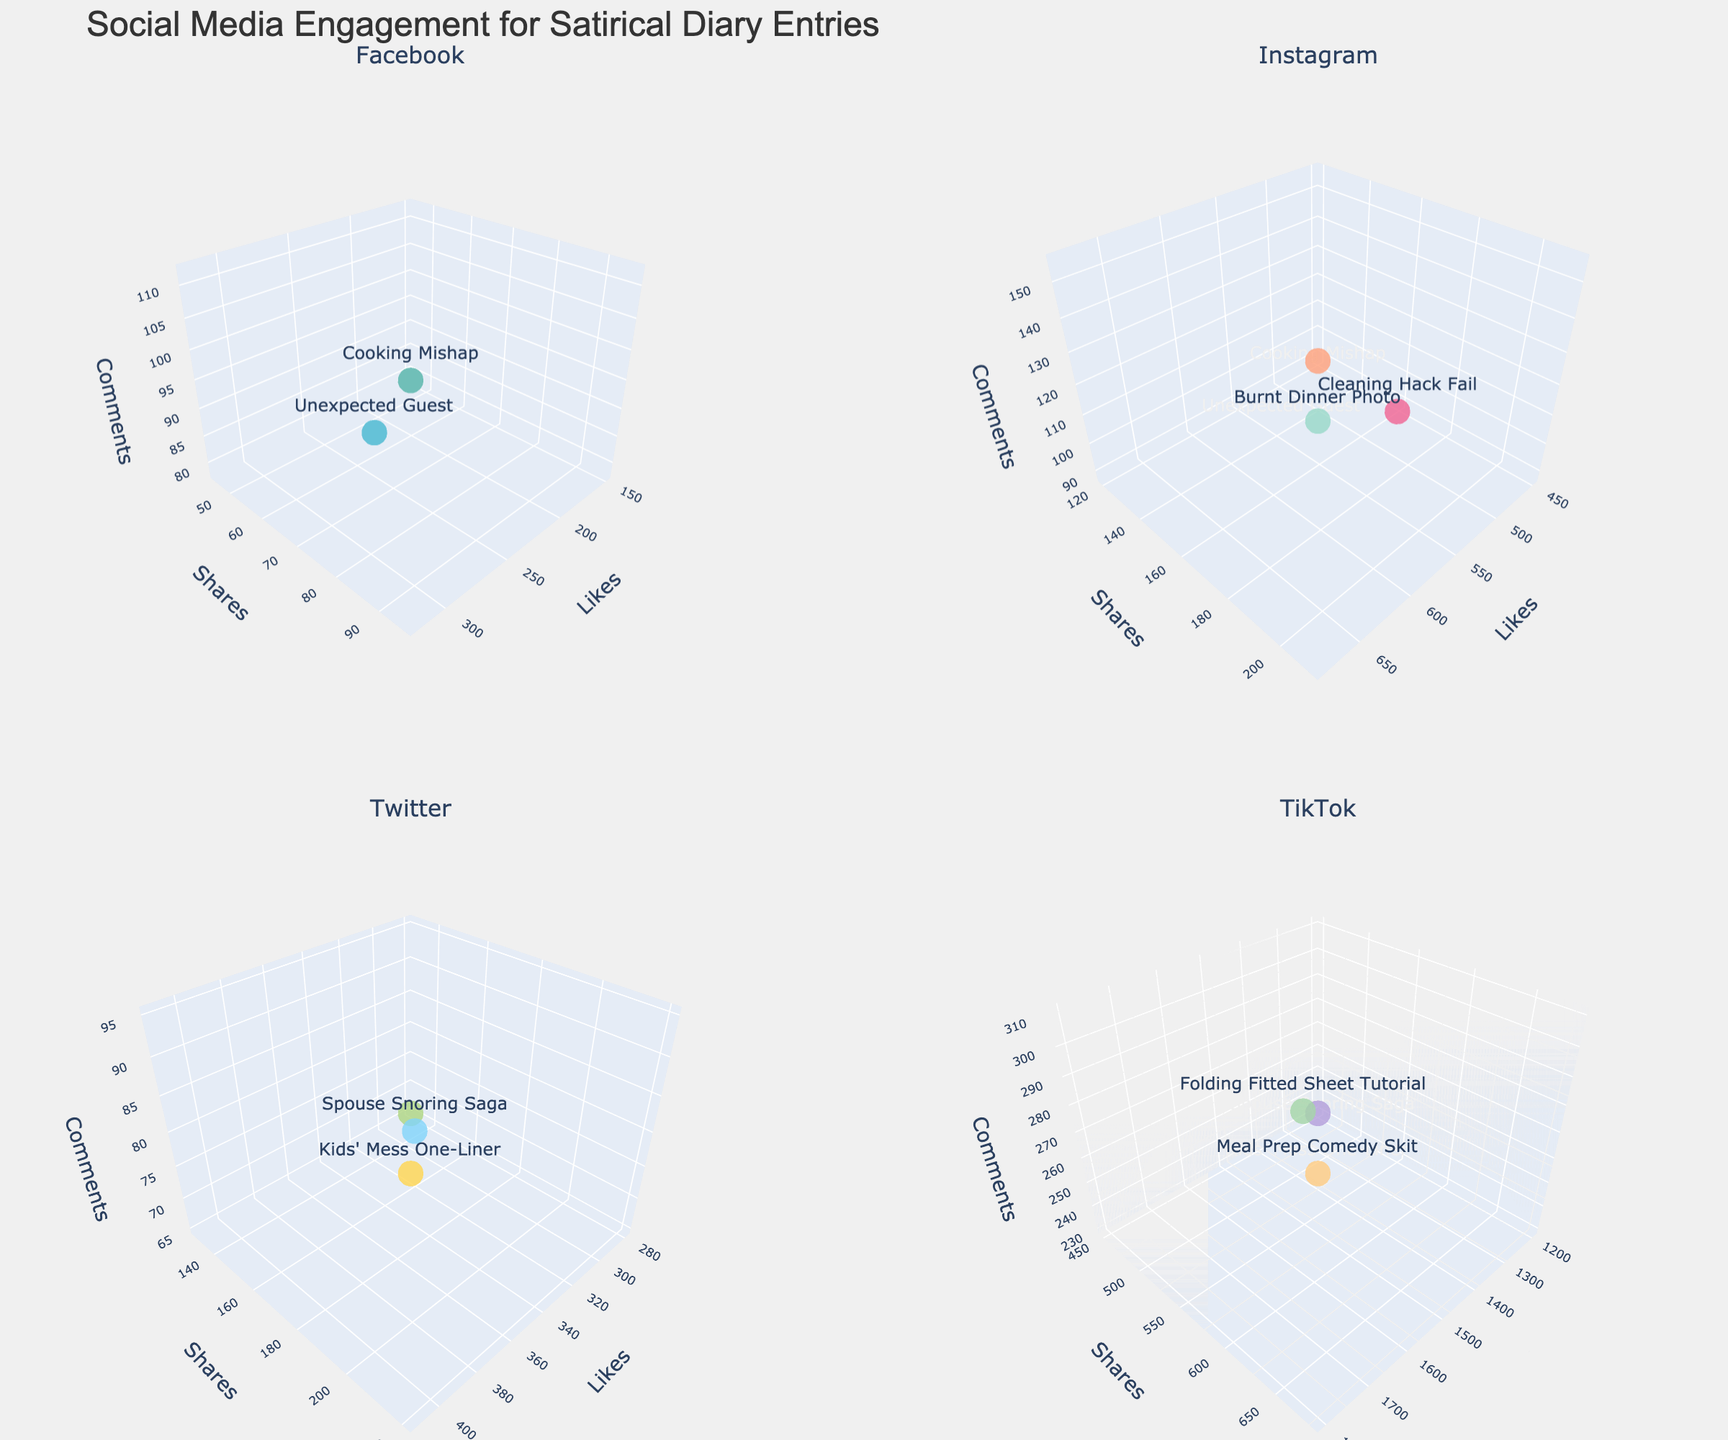What platforms are represented in the figure? The subplot titles indicate the platforms represented: Facebook, Instagram, Twitter, and TikTok.
Answer: Facebook, Instagram, Twitter, TikTok How many post types are plotted for Facebook? Looking at the subplot for Facebook, there are three distinct colored markers, each labeled with a different post type.
Answer: 3 Which platform has the post type with the highest number of likes? In the subplot for TikTok, the "Meal Prep Comedy Skit" has 1800 likes, which is the highest number of likes among all post types across all platforms.
Answer: TikTok Compare the shares of "Burnt Dinner Photo" on Instagram and "Spouse Snoring Saga" on Twitter. Which one has more shares? "Burnt Dinner Photo" on Instagram has 210 shares, while "Spouse Snoring Saga" on Twitter has 180 shares. Therefore, "Burnt Dinner Photo" has more shares.
Answer: Burnt Dinner Photo What is the color used for the "Folding Fitted Sheet Tutorial" post type on TikTok? The color map indicates that "Folding Fitted Sheet Tutorial" is represented by a shade of light green.
Answer: Light Green How many comments does "Grocery List Haiku" on Twitter have, and is this more or less than the comments on "Daily Chore Rant" on Facebook? "Grocery List Haiku" on Twitter has 65 comments, while "Daily Chore Rant" on Facebook has 78 comments. So, it has fewer comments.
Answer: Less What post type has the least engagement (combining likes, shares, and comments) on LinkedIn? "Work-Life Balance Satire" on LinkedIn has the lowest engagement with 85 likes, 30 shares, and 42 comments, summing to 157. This is lower than the other post types on LinkedIn.
Answer: Work-Life Balance Satire Which platform shows a wider spread of comments among its post types: Instagram or Twitter? Examining the range of the z-axes (comments) for Instagram and Twitter, Twitter has a wider spread with comments ranging from 65 to 95, while Instagram ranges from 88 to 155.
Answer: Twitter Which features are shown along the axes in the plot? The axes are labeled with Likes, Shares, and Comments, representing the three dimensions of engagement metrics in the plot.
Answer: Likes, Shares, Comments How many comments does the "Networking from Home Humor" post type have on LinkedIn according to the hover text? The hover text for the "Networking from Home Humor" post type on LinkedIn shows it has 48 comments.
Answer: 48 